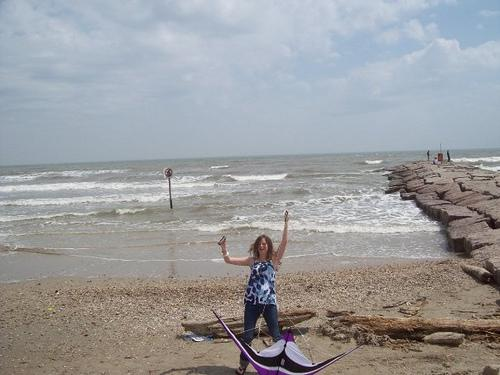What activity is she participating in?

Choices:
A) swimming
B) frisbee
C) kite flying
D) fishing kite flying 